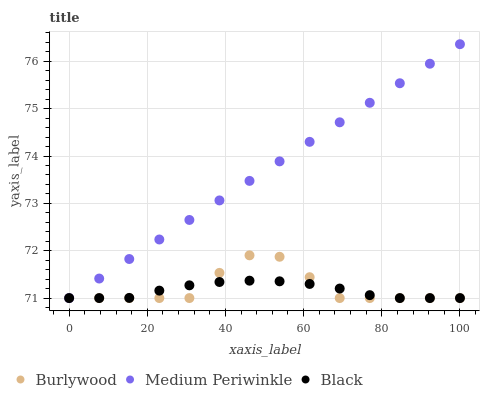Does Black have the minimum area under the curve?
Answer yes or no. Yes. Does Medium Periwinkle have the maximum area under the curve?
Answer yes or no. Yes. Does Medium Periwinkle have the minimum area under the curve?
Answer yes or no. No. Does Black have the maximum area under the curve?
Answer yes or no. No. Is Medium Periwinkle the smoothest?
Answer yes or no. Yes. Is Burlywood the roughest?
Answer yes or no. Yes. Is Black the smoothest?
Answer yes or no. No. Is Black the roughest?
Answer yes or no. No. Does Burlywood have the lowest value?
Answer yes or no. Yes. Does Medium Periwinkle have the highest value?
Answer yes or no. Yes. Does Black have the highest value?
Answer yes or no. No. Does Medium Periwinkle intersect Burlywood?
Answer yes or no. Yes. Is Medium Periwinkle less than Burlywood?
Answer yes or no. No. Is Medium Periwinkle greater than Burlywood?
Answer yes or no. No. 